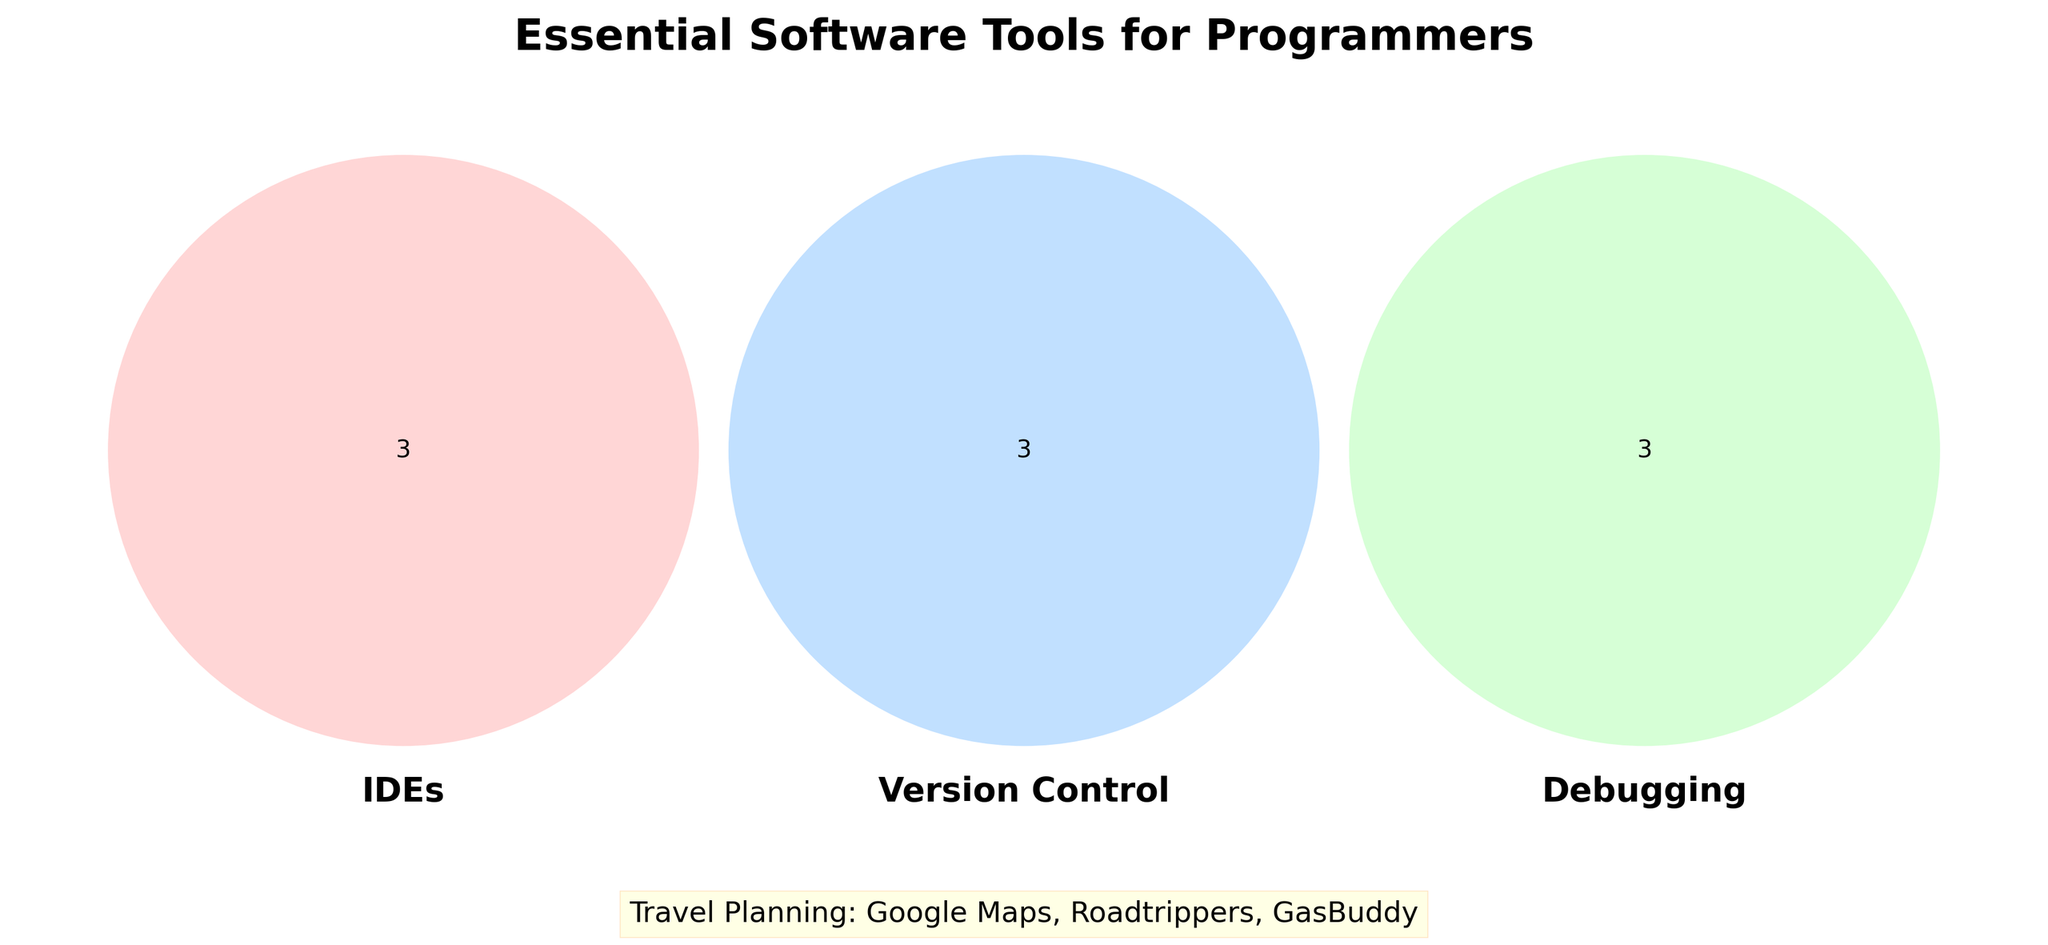How many categories are displayed in the center of the Venn Diagram? The center of a Venn Diagram represents the intersection of all sets. Here, three categories (IDEs, Version Control, Debugging) are displayed.
Answer: 3 What is the unique tool listed under Version Control that is not in the other categories? In the Venn Diagram, the unique tools under Version Control are Git, GitHub, and GitLab. These tools do not overlap with other categories.
Answer: Git, GitHub, GitLab Which section of the Venn Diagram has the greatest number of tools? By visually inspecting the figure, the IDEs section has the most tools listed (Visual Studio Code, PyCharm, IntelliJ IDEA) without considering overlaps.
Answer: IDEs Name the tools listed for Travel Planning displayed outside the Venn Diagram. At the bottom of the figure, tools for Travel Planning are listed separately, and they include Google Maps, Roadtrippers, GasBuddy.
Answer: Google Maps, Roadtrippers, GasBuddy Where do Chrome DevTools and Slack appear in the Venn Diagram? Chrome DevTools is in the Debugging section, and Slack is in the Collaboration section. These tools are unique to their respective sections.
Answer: Chrome DevTools: Debugging, Slack: Collaboration How many shared tools are there between IDEs and Debugging categories (if any)? In a Venn Diagram, the shared tools between two categories would appear in the overlapping section between the two. There are no overlapping tools shown between IDEs and Debugging.
Answer: 0 Which category’s tools are not overlapped with any other category in the Venn Diagram? The categories with no overlaps in the Venn Diagram are IDEs and Debugging, meaning each tool in these categories does not intersect with tools from another category.
Answer: IDEs, Debugging What are the three set colors used in the Venn Diagram? The colors assigned to the sets (IDEs, Version Control, Debugging) are shades of red, blue, and green.
Answer: Red, Blue, Green Identify tools that belong exclusively to the Debugging category. The tools listed only in the Debugging category within the Venn Diagram are Chrome DevTools, GDB, and Postman.
Answer: Chrome DevTools, GDB, Postman 